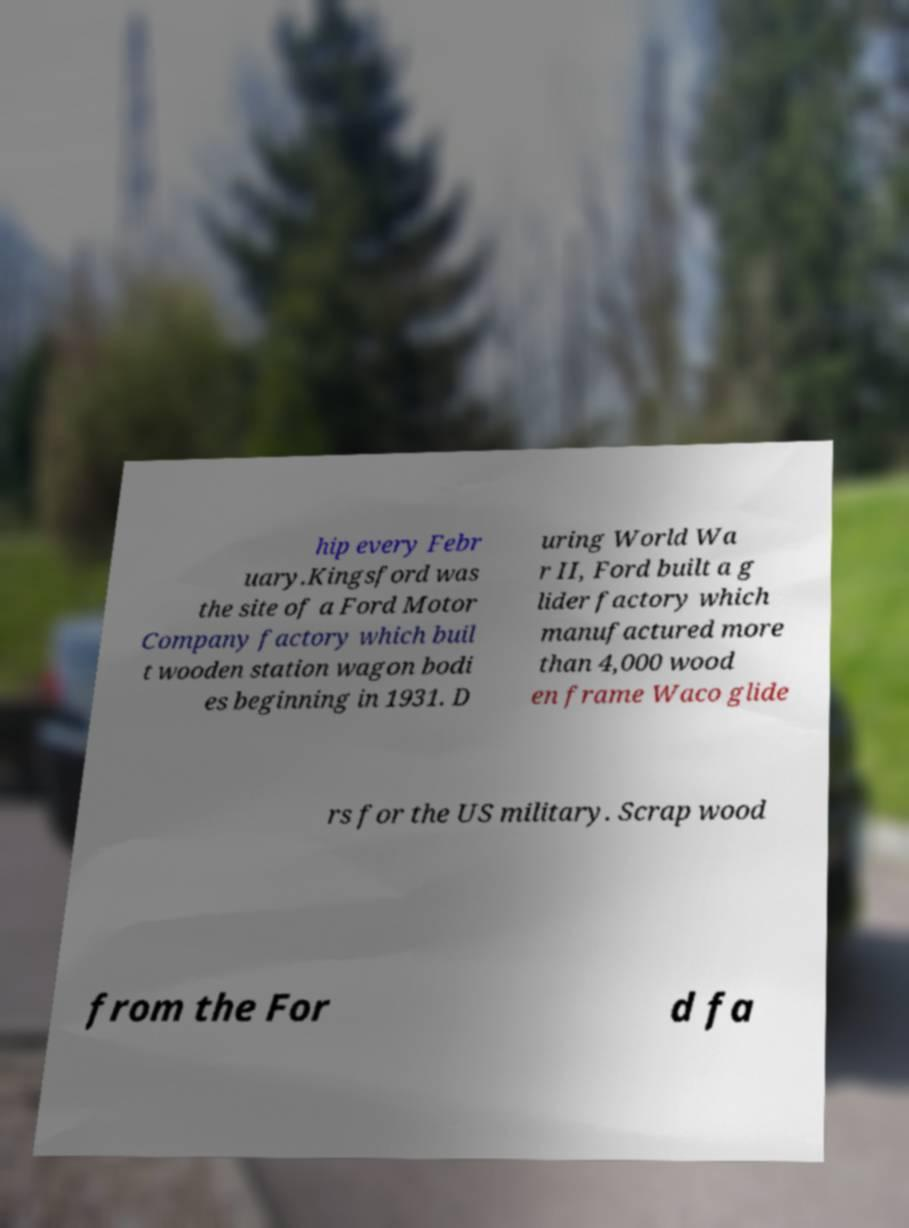Could you extract and type out the text from this image? hip every Febr uary.Kingsford was the site of a Ford Motor Company factory which buil t wooden station wagon bodi es beginning in 1931. D uring World Wa r II, Ford built a g lider factory which manufactured more than 4,000 wood en frame Waco glide rs for the US military. Scrap wood from the For d fa 